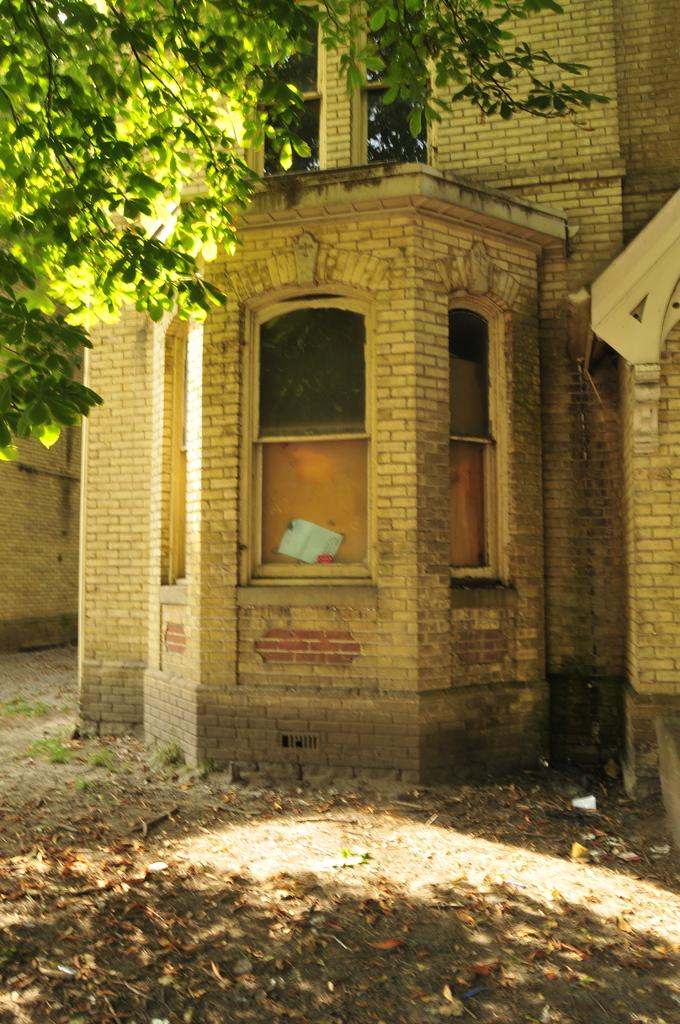What type of structure is visible in the image? There is a building in the image. What natural elements can be seen in the image? There are trees in the image. What is present on the ground in the image? Shredded leaves are present on the ground in the image. Can you see a wave crashing on the shore in the image? There is no wave or shore present in the image; it features a building and trees. Is there a pig visible in the image? There is no pig present in the image. 